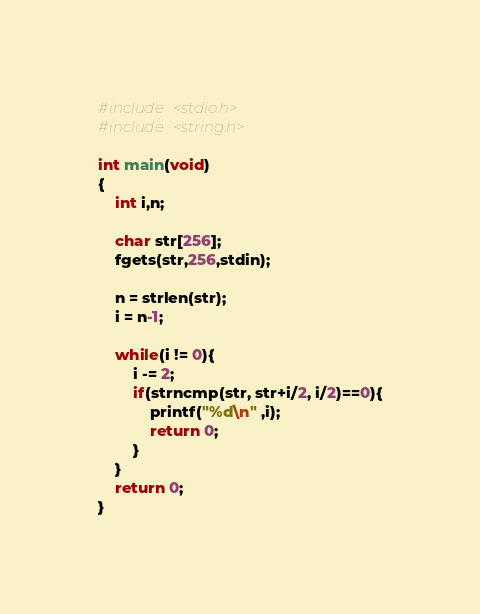Convert code to text. <code><loc_0><loc_0><loc_500><loc_500><_C_>#include <stdio.h>
#include <string.h>

int main(void)
{
    int i,n;
    
    char str[256];
    fgets(str,256,stdin);
    
    n = strlen(str);
    i = n-1;
    
    while(i != 0){
        i -= 2;
        if(strncmp(str, str+i/2, i/2)==0){
            printf("%d\n" ,i);
            return 0;
        }
    }
    return 0;
}</code> 